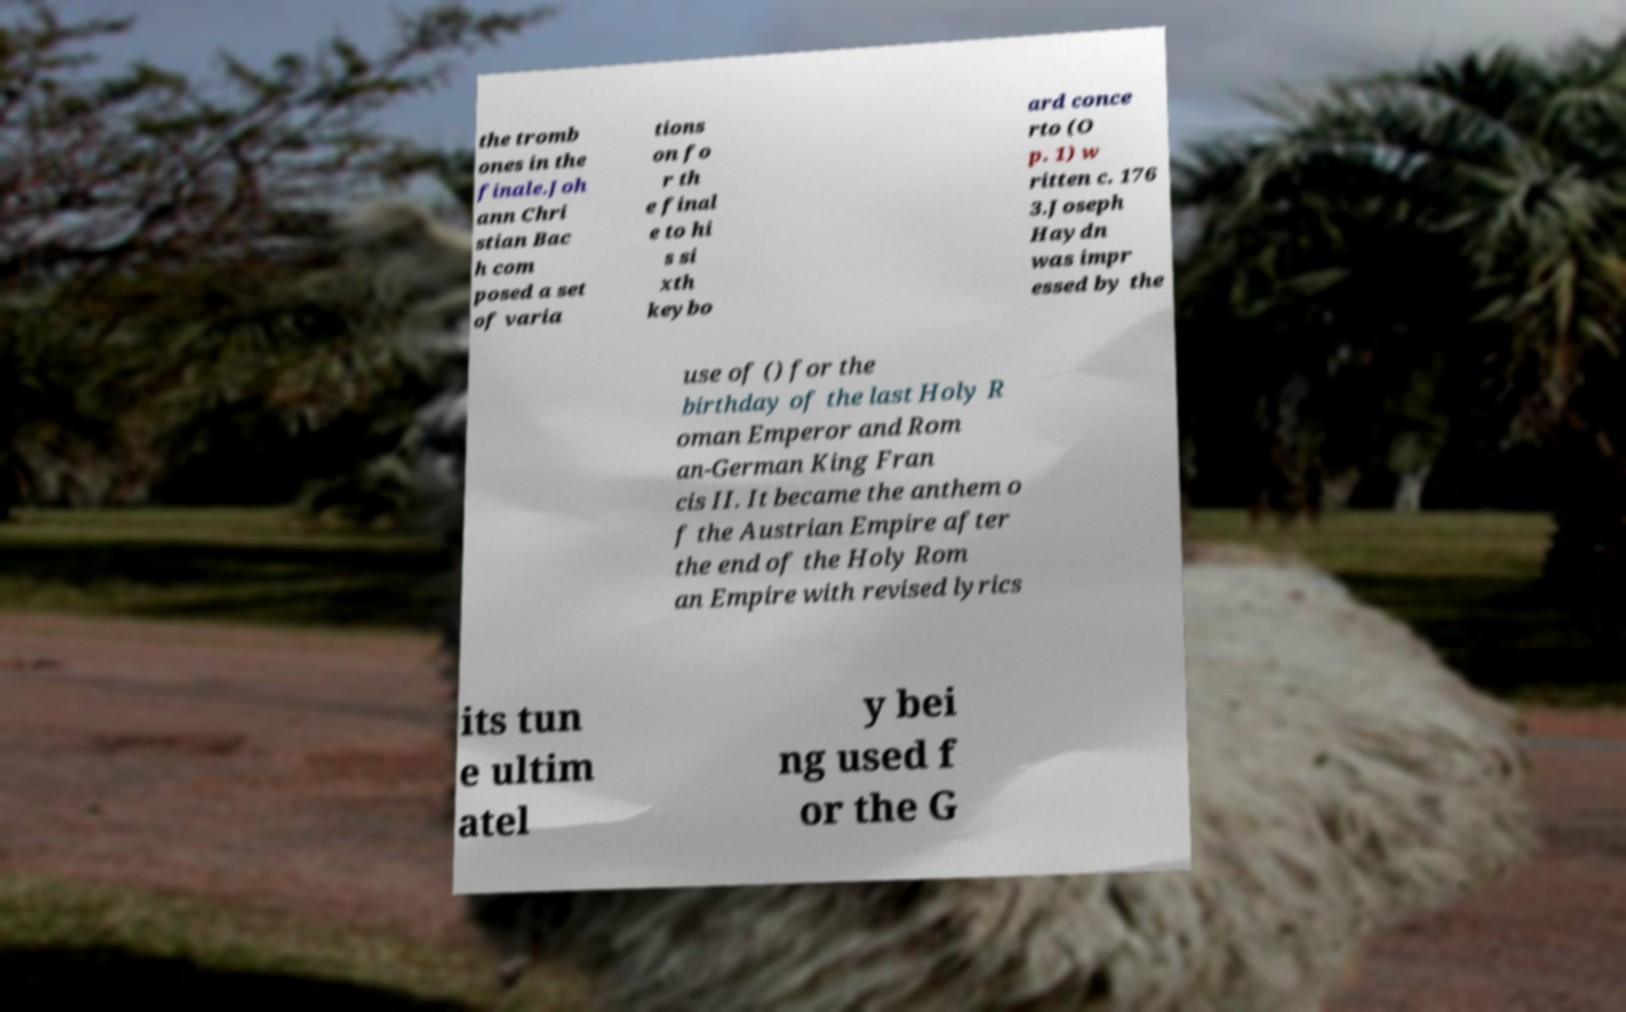Please identify and transcribe the text found in this image. the tromb ones in the finale.Joh ann Chri stian Bac h com posed a set of varia tions on fo r th e final e to hi s si xth keybo ard conce rto (O p. 1) w ritten c. 176 3.Joseph Haydn was impr essed by the use of () for the birthday of the last Holy R oman Emperor and Rom an-German King Fran cis II. It became the anthem o f the Austrian Empire after the end of the Holy Rom an Empire with revised lyrics its tun e ultim atel y bei ng used f or the G 